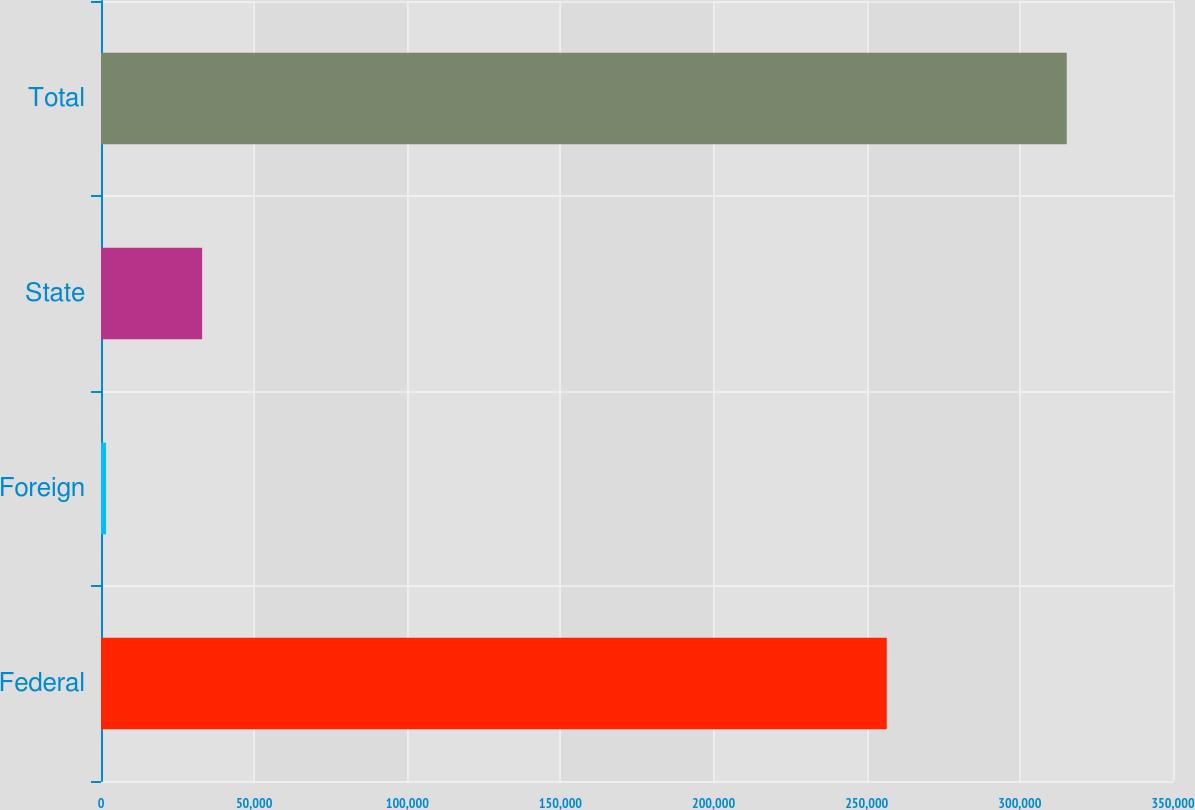Convert chart. <chart><loc_0><loc_0><loc_500><loc_500><bar_chart><fcel>Federal<fcel>Foreign<fcel>State<fcel>Total<nl><fcel>256545<fcel>1655<fcel>33020.4<fcel>315309<nl></chart> 